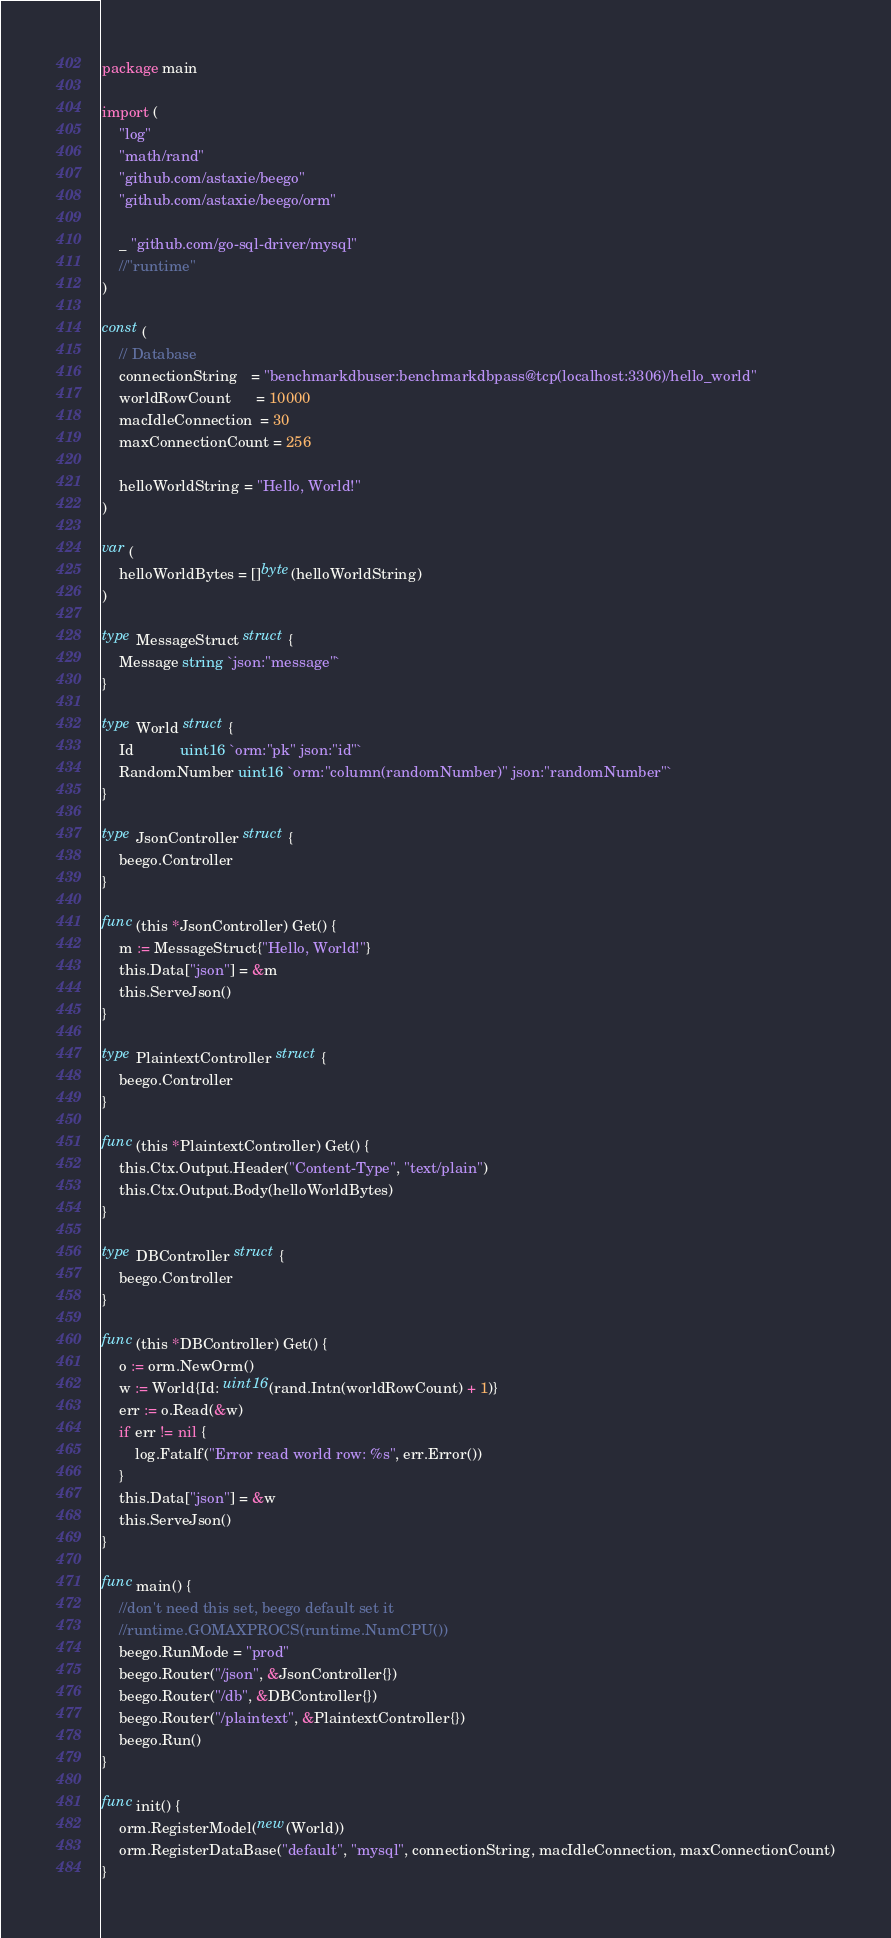Convert code to text. <code><loc_0><loc_0><loc_500><loc_500><_Go_>package main

import (
	"log"
	"math/rand"
	"github.com/astaxie/beego"
	"github.com/astaxie/beego/orm"

	_ "github.com/go-sql-driver/mysql"
	//"runtime"
)

const (
	// Database
	connectionString   = "benchmarkdbuser:benchmarkdbpass@tcp(localhost:3306)/hello_world"
	worldRowCount      = 10000
	macIdleConnection  = 30
	maxConnectionCount = 256

	helloWorldString = "Hello, World!"
)

var (
	helloWorldBytes = []byte(helloWorldString)
)

type MessageStruct struct {
	Message string `json:"message"`
}

type World struct {
	Id           uint16 `orm:"pk" json:"id"`
	RandomNumber uint16 `orm:"column(randomNumber)" json:"randomNumber"`
}

type JsonController struct {
	beego.Controller
}

func (this *JsonController) Get() {
	m := MessageStruct{"Hello, World!"}
	this.Data["json"] = &m
	this.ServeJson()
}

type PlaintextController struct {
	beego.Controller
}

func (this *PlaintextController) Get() {
	this.Ctx.Output.Header("Content-Type", "text/plain")
	this.Ctx.Output.Body(helloWorldBytes)
}

type DBController struct {
	beego.Controller
}

func (this *DBController) Get() {
	o := orm.NewOrm()
	w := World{Id: uint16(rand.Intn(worldRowCount) + 1)}
	err := o.Read(&w)
	if err != nil {
		log.Fatalf("Error read world row: %s", err.Error())
	}
	this.Data["json"] = &w
	this.ServeJson()
}

func main() {
	//don't need this set, beego default set it
	//runtime.GOMAXPROCS(runtime.NumCPU())
	beego.RunMode = "prod"
	beego.Router("/json", &JsonController{})
	beego.Router("/db", &DBController{})
	beego.Router("/plaintext", &PlaintextController{})
	beego.Run()
}

func init() {
	orm.RegisterModel(new(World))
	orm.RegisterDataBase("default", "mysql", connectionString, macIdleConnection, maxConnectionCount)
}
</code> 